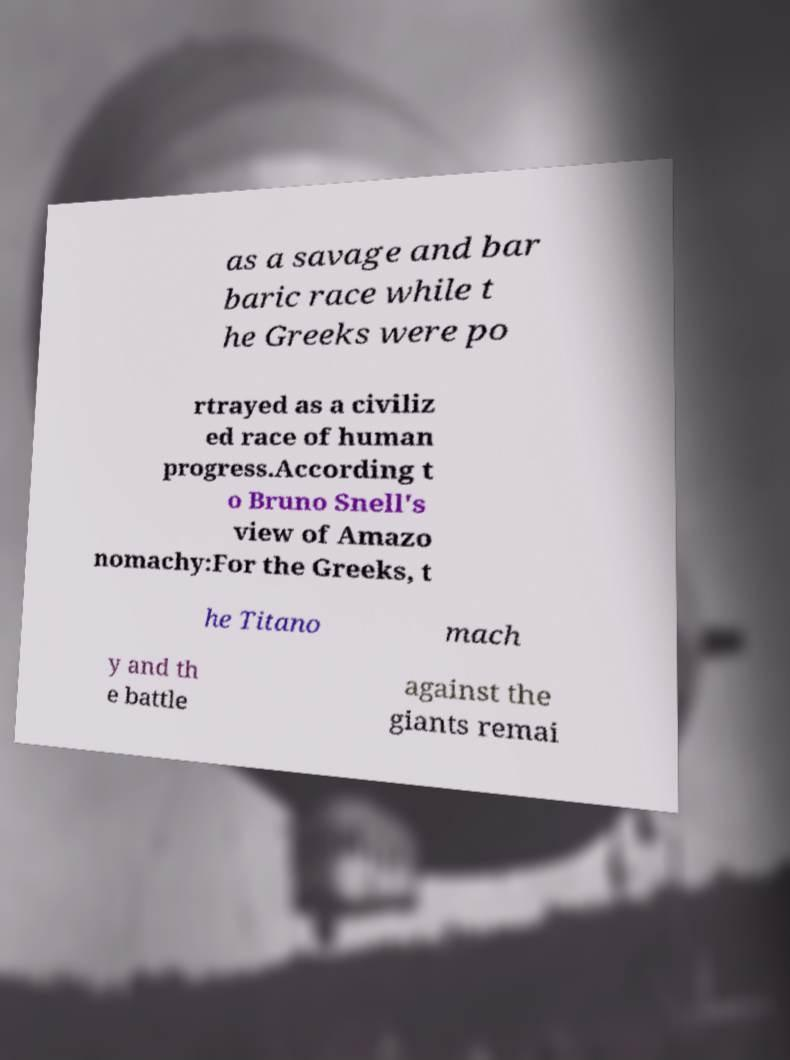Please read and relay the text visible in this image. What does it say? as a savage and bar baric race while t he Greeks were po rtrayed as a civiliz ed race of human progress.According t o Bruno Snell's view of Amazo nomachy:For the Greeks, t he Titano mach y and th e battle against the giants remai 